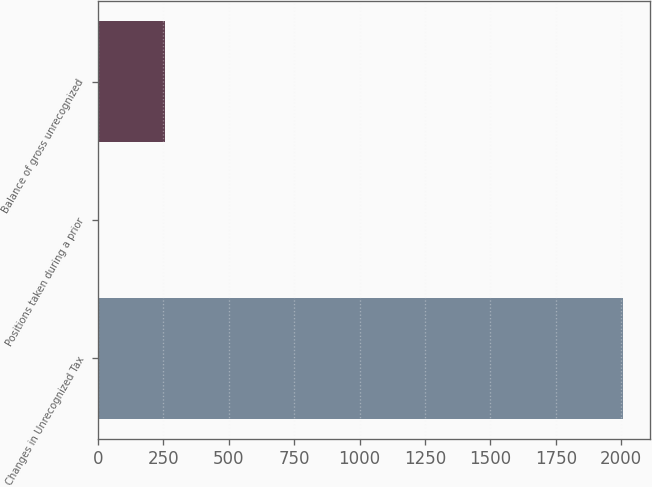Convert chart. <chart><loc_0><loc_0><loc_500><loc_500><bar_chart><fcel>Changes in Unrecognized Tax<fcel>Positions taken during a prior<fcel>Balance of gross unrecognized<nl><fcel>2008<fcel>3<fcel>257<nl></chart> 